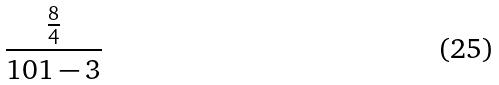Convert formula to latex. <formula><loc_0><loc_0><loc_500><loc_500>\frac { \frac { 8 } { 4 } } { 1 0 1 - 3 }</formula> 